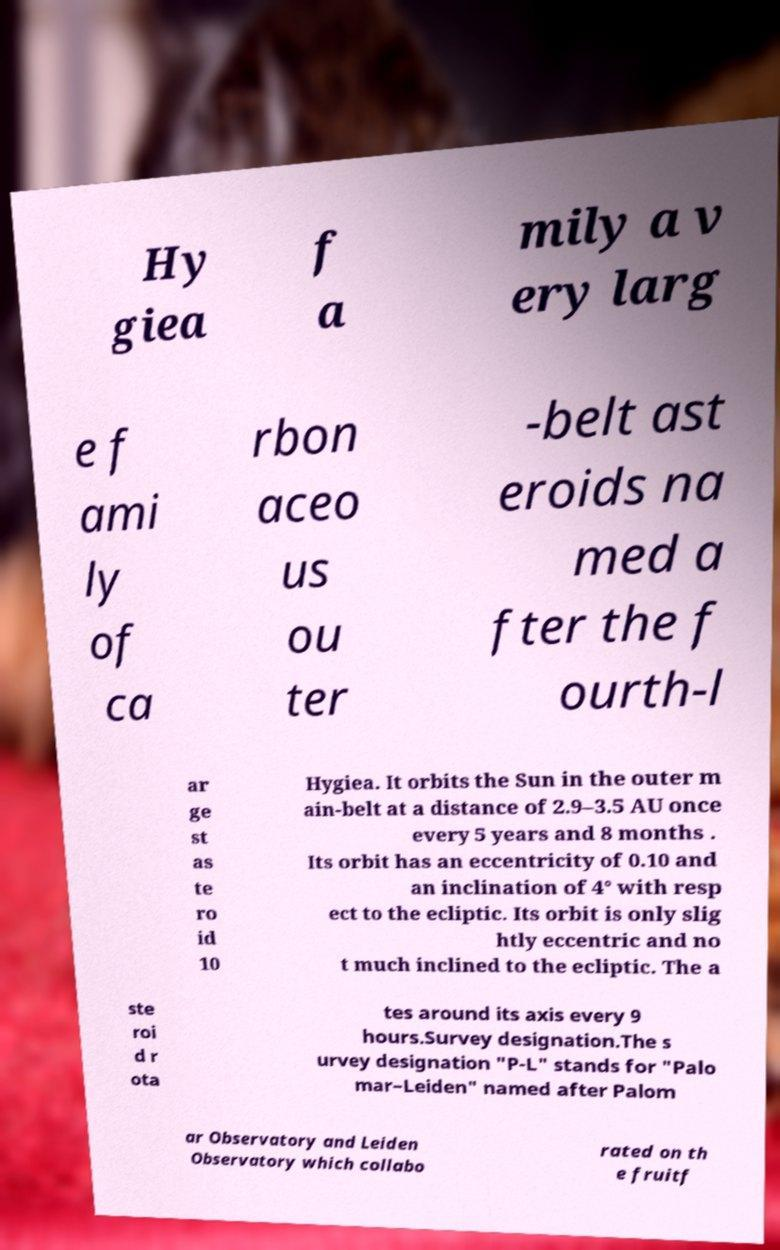I need the written content from this picture converted into text. Can you do that? Hy giea f a mily a v ery larg e f ami ly of ca rbon aceo us ou ter -belt ast eroids na med a fter the f ourth-l ar ge st as te ro id 10 Hygiea. It orbits the Sun in the outer m ain-belt at a distance of 2.9–3.5 AU once every 5 years and 8 months . Its orbit has an eccentricity of 0.10 and an inclination of 4° with resp ect to the ecliptic. Its orbit is only slig htly eccentric and no t much inclined to the ecliptic. The a ste roi d r ota tes around its axis every 9 hours.Survey designation.The s urvey designation "P-L" stands for "Palo mar–Leiden" named after Palom ar Observatory and Leiden Observatory which collabo rated on th e fruitf 